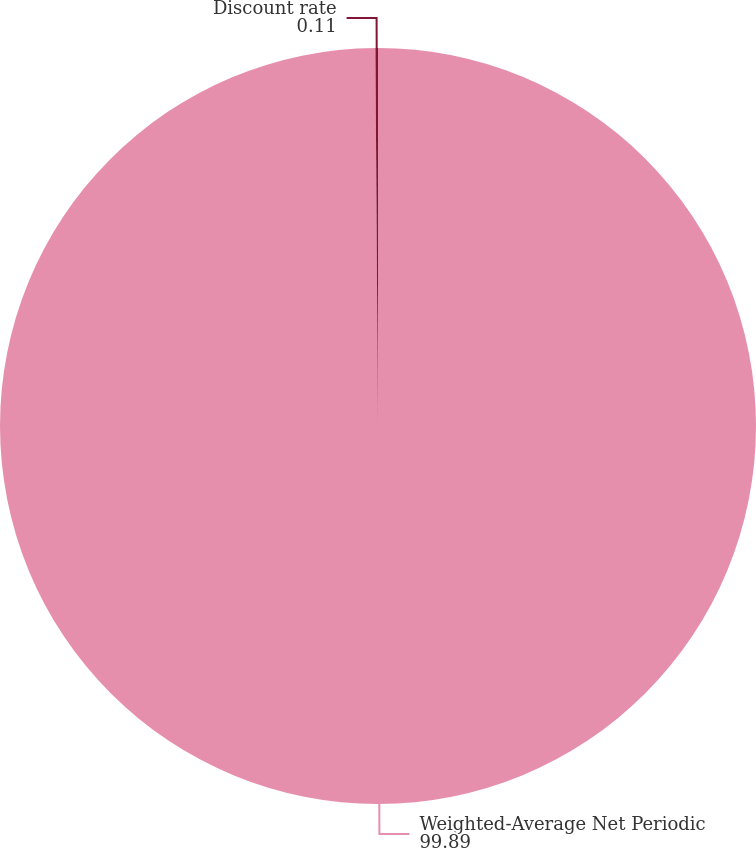<chart> <loc_0><loc_0><loc_500><loc_500><pie_chart><fcel>Weighted-Average Net Periodic<fcel>Discount rate<nl><fcel>99.89%<fcel>0.11%<nl></chart> 